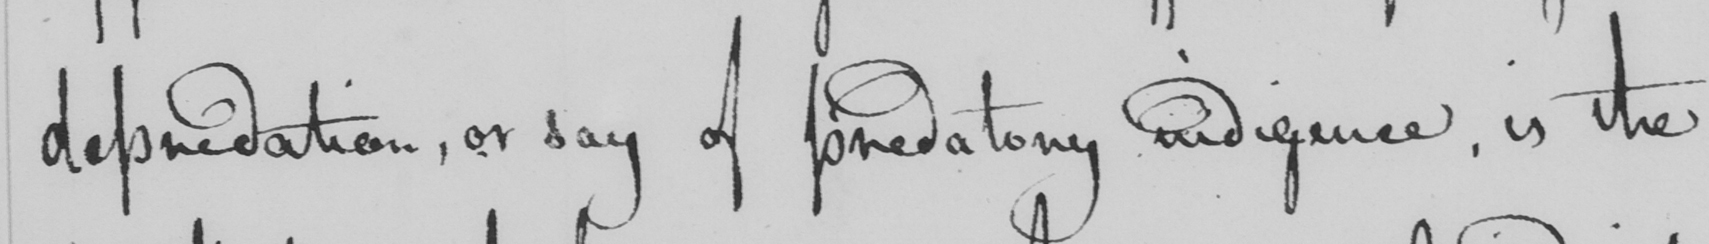Can you read and transcribe this handwriting? depredation, or say of predatory indigence, is the 